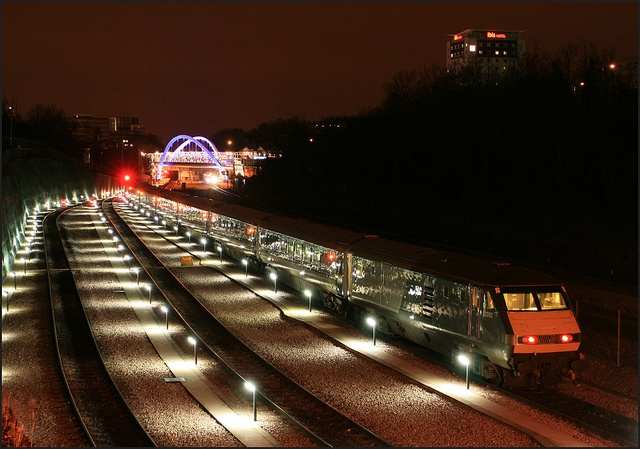Describe the objects in this image and their specific colors. I can see a train in black, darkgreen, maroon, and gray tones in this image. 